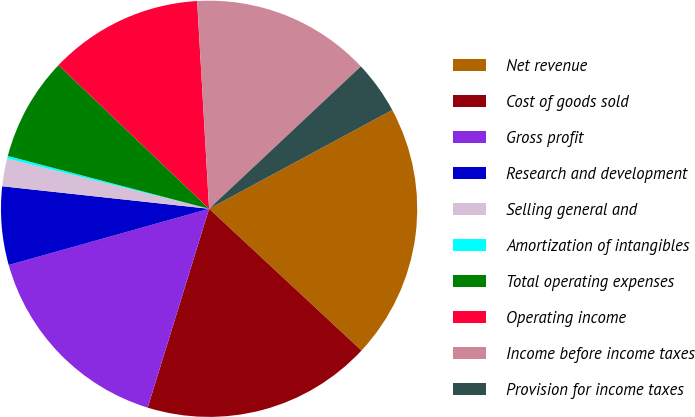Convert chart. <chart><loc_0><loc_0><loc_500><loc_500><pie_chart><fcel>Net revenue<fcel>Cost of goods sold<fcel>Gross profit<fcel>Research and development<fcel>Selling general and<fcel>Amortization of intangibles<fcel>Total operating expenses<fcel>Operating income<fcel>Income before income taxes<fcel>Provision for income taxes<nl><fcel>19.8%<fcel>17.84%<fcel>15.88%<fcel>6.08%<fcel>2.16%<fcel>0.2%<fcel>8.04%<fcel>11.96%<fcel>13.92%<fcel>4.12%<nl></chart> 